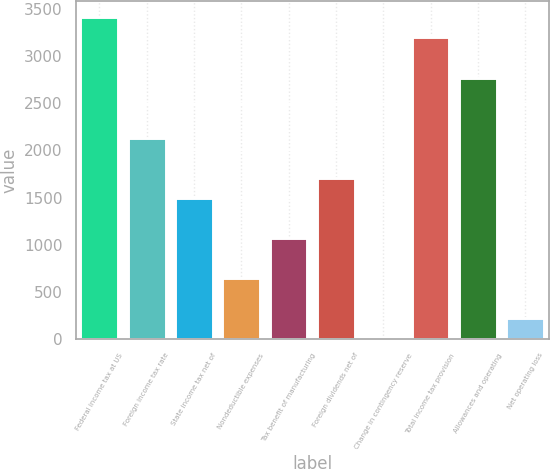Convert chart. <chart><loc_0><loc_0><loc_500><loc_500><bar_chart><fcel>Federal income tax at US<fcel>Foreign income tax rate<fcel>State income tax net of<fcel>Nondeductible expenses<fcel>Tax benefit of manufacturing<fcel>Foreign dividends net of<fcel>Change in contingency reserve<fcel>Total income tax provision<fcel>Allowances and operating<fcel>Net operating loss<nl><fcel>3410.8<fcel>2134<fcel>1495.6<fcel>644.4<fcel>1070<fcel>1708.4<fcel>6<fcel>3198<fcel>2772.4<fcel>218.8<nl></chart> 